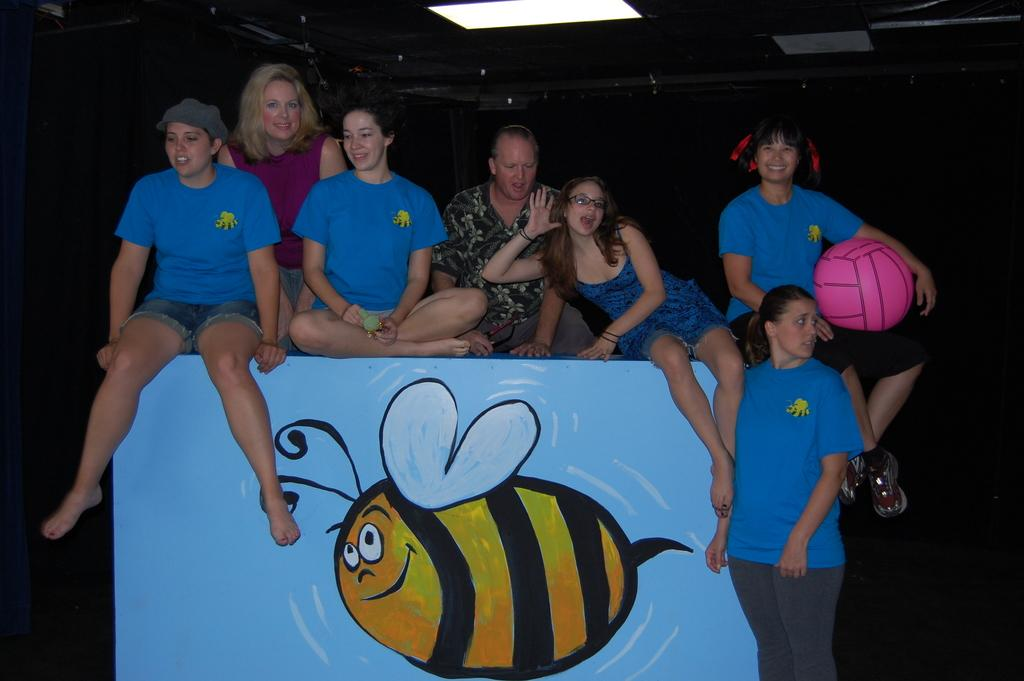What are the women in the image doing? The women in the image are sitting on a table and laughing. Can you describe the standing woman in the image? There is a woman standing on the right side of the image, and she is looking at somewhere. What type of feast is being prepared by the police in the image? There are no police or feast present in the image. What type of stew is being cooked by the women in the image? There is no stew being cooked in the image; the women are sitting on a table and laughing. 